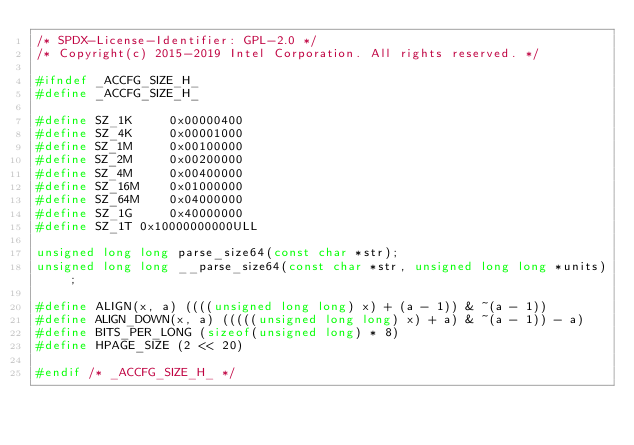Convert code to text. <code><loc_0><loc_0><loc_500><loc_500><_C_>/* SPDX-License-Identifier: GPL-2.0 */
/* Copyright(c) 2015-2019 Intel Corporation. All rights reserved. */

#ifndef _ACCFG_SIZE_H_
#define _ACCFG_SIZE_H_

#define SZ_1K     0x00000400
#define SZ_4K     0x00001000
#define SZ_1M     0x00100000
#define SZ_2M     0x00200000
#define SZ_4M     0x00400000
#define SZ_16M    0x01000000
#define SZ_64M    0x04000000
#define SZ_1G     0x40000000
#define SZ_1T 0x10000000000ULL

unsigned long long parse_size64(const char *str);
unsigned long long __parse_size64(const char *str, unsigned long long *units);

#define ALIGN(x, a) ((((unsigned long long) x) + (a - 1)) & ~(a - 1))
#define ALIGN_DOWN(x, a) (((((unsigned long long) x) + a) & ~(a - 1)) - a)
#define BITS_PER_LONG (sizeof(unsigned long) * 8)
#define HPAGE_SIZE (2 << 20)

#endif /* _ACCFG_SIZE_H_ */
</code> 